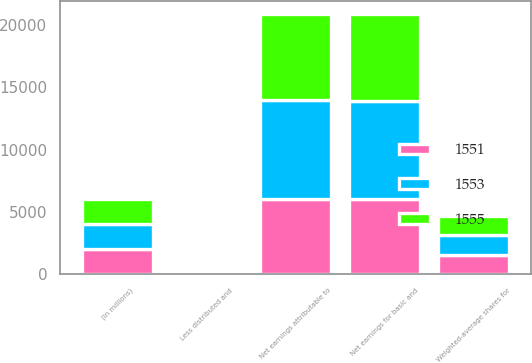<chart> <loc_0><loc_0><loc_500><loc_500><stacked_bar_chart><ecel><fcel>(in millions)<fcel>Net earnings attributable to<fcel>Less distributed and<fcel>Net earnings for basic and<fcel>Weighted-average shares for<nl><fcel>1553<fcel>2018<fcel>7911<fcel>16<fcel>7895<fcel>1555<nl><fcel>1551<fcel>2017<fcel>6035<fcel>14<fcel>6021<fcel>1553<nl><fcel>1555<fcel>2016<fcel>6967<fcel>19<fcel>6948<fcel>1551<nl></chart> 